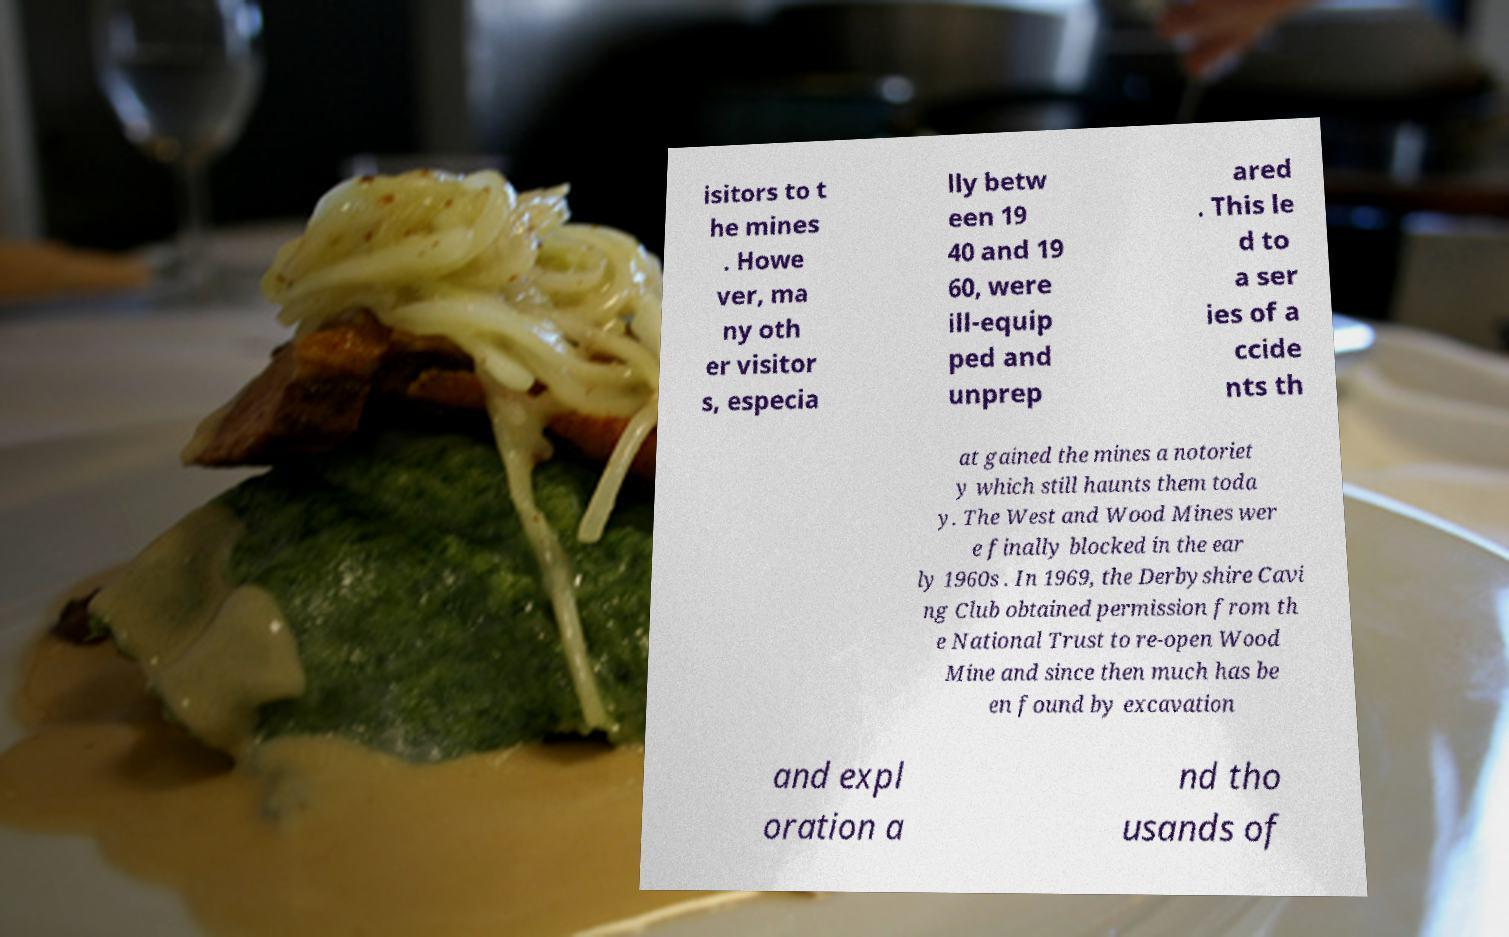What messages or text are displayed in this image? I need them in a readable, typed format. isitors to t he mines . Howe ver, ma ny oth er visitor s, especia lly betw een 19 40 and 19 60, were ill-equip ped and unprep ared . This le d to a ser ies of a ccide nts th at gained the mines a notoriet y which still haunts them toda y. The West and Wood Mines wer e finally blocked in the ear ly 1960s . In 1969, the Derbyshire Cavi ng Club obtained permission from th e National Trust to re-open Wood Mine and since then much has be en found by excavation and expl oration a nd tho usands of 